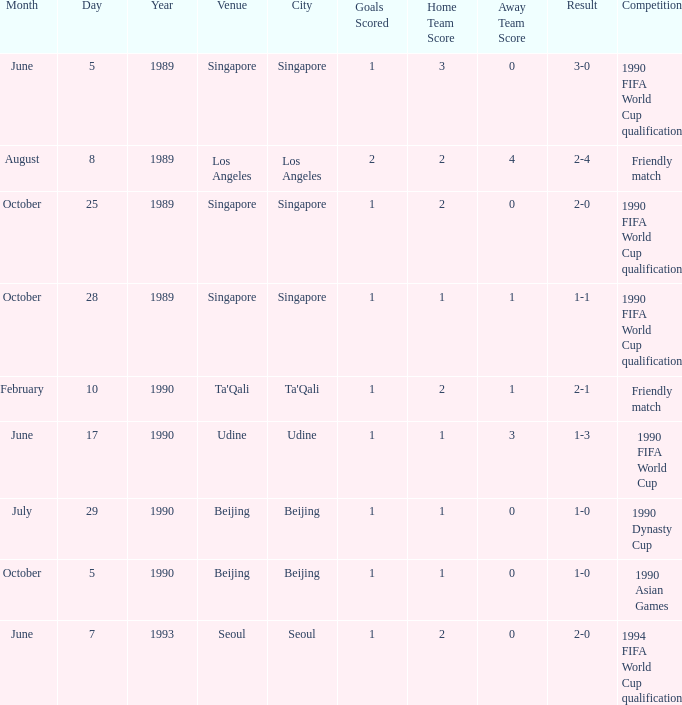What was the venue where the result was 2-1? Ta'Qali. 